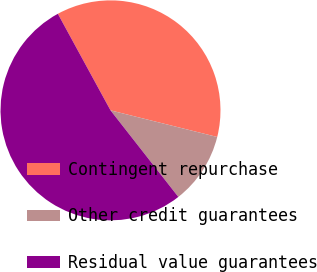Convert chart to OTSL. <chart><loc_0><loc_0><loc_500><loc_500><pie_chart><fcel>Contingent repurchase<fcel>Other credit guarantees<fcel>Residual value guarantees<nl><fcel>36.84%<fcel>10.53%<fcel>52.63%<nl></chart> 